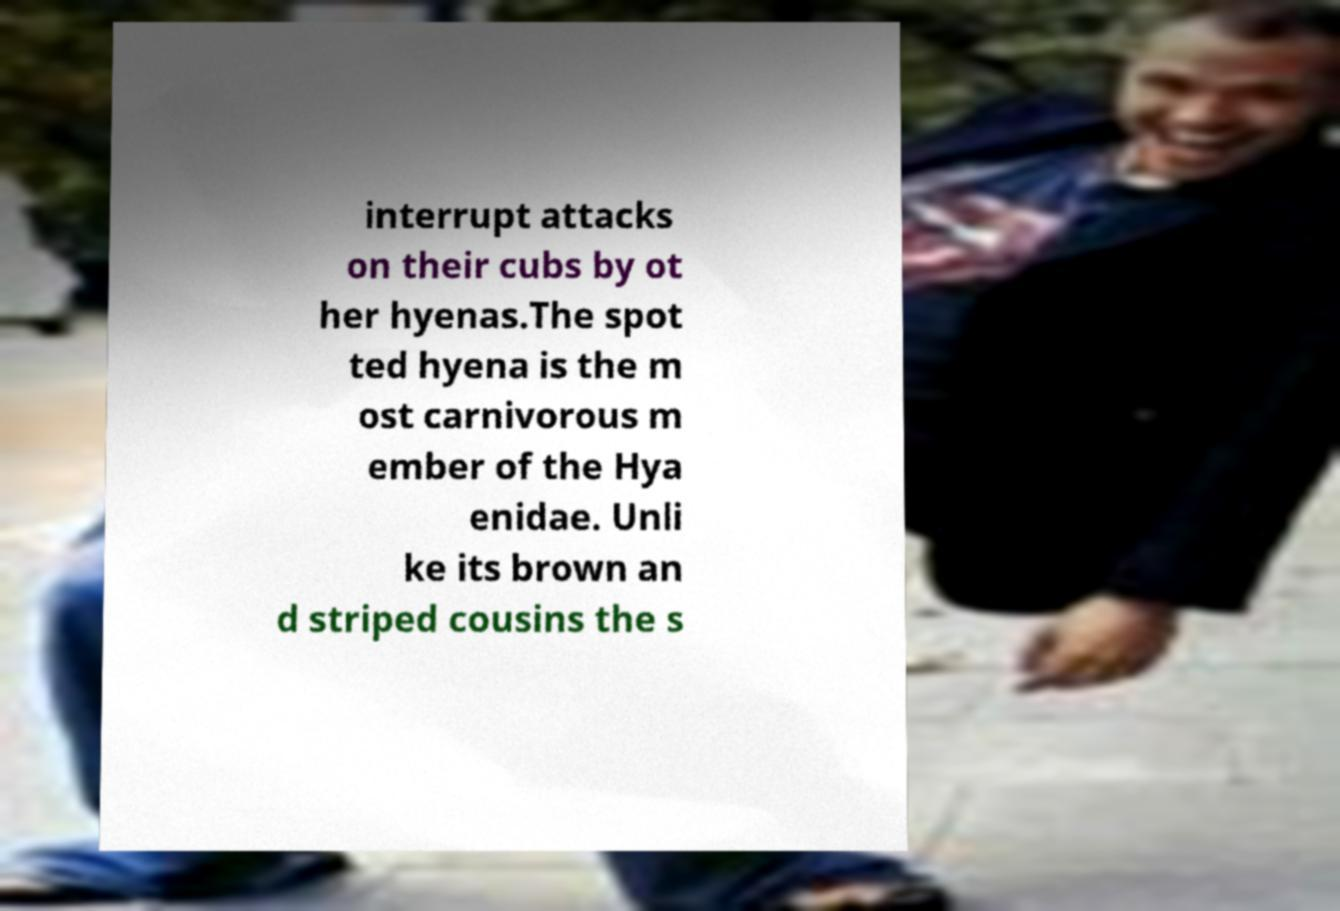What messages or text are displayed in this image? I need them in a readable, typed format. interrupt attacks on their cubs by ot her hyenas.The spot ted hyena is the m ost carnivorous m ember of the Hya enidae. Unli ke its brown an d striped cousins the s 